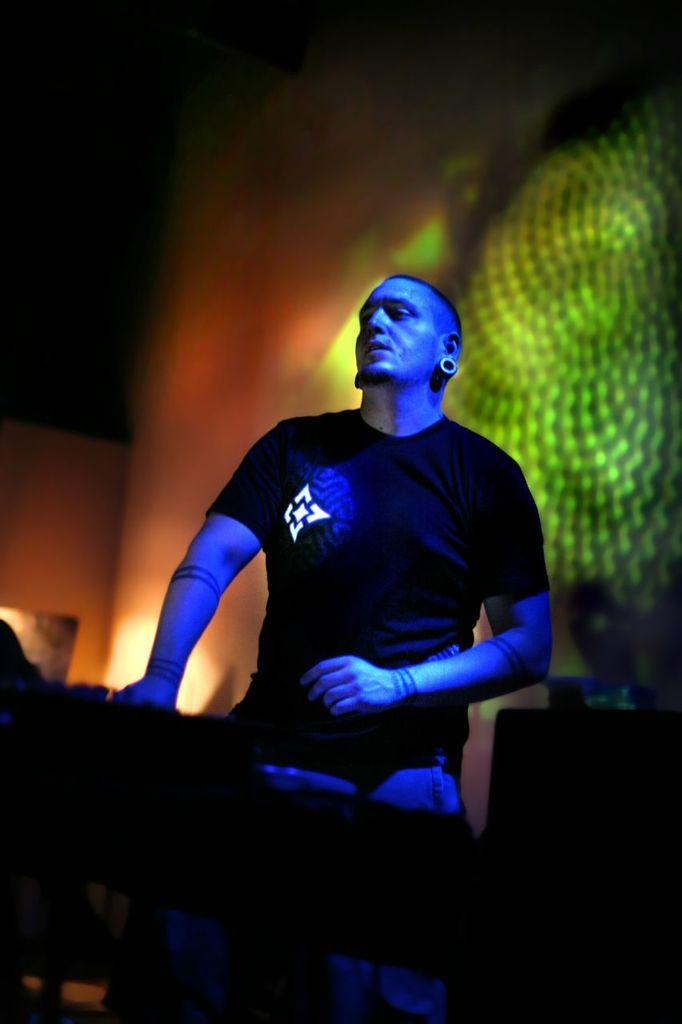What is the main subject of the picture? The main subject of the picture is a man. What is the man doing in the picture? The man is standing in the picture. What is the man wearing in the picture? The man is wearing a black shirt in the picture. What can be seen in the background of the picture? There are lights focusing on the wall in the background of the picture. What type of game is the man playing in the picture? There is no game being played in the picture; the man is simply standing. What kind of yam is being used as a prop in the picture? There is no yam present in the picture. 